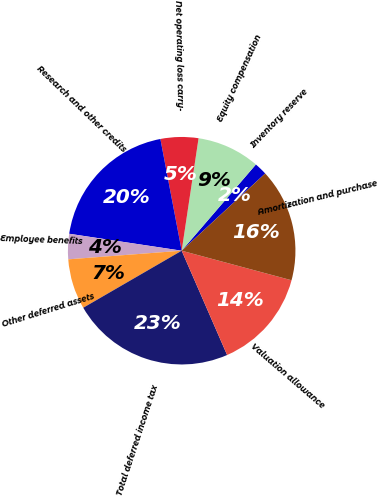<chart> <loc_0><loc_0><loc_500><loc_500><pie_chart><fcel>Inventory reserve<fcel>Equity compensation<fcel>Net operating loss carry-<fcel>Research and other credits<fcel>Employee benefits<fcel>Other deferred assets<fcel>Total deferred income tax<fcel>Valuation allowance<fcel>Amortization and purchase<nl><fcel>1.81%<fcel>8.94%<fcel>5.37%<fcel>19.62%<fcel>3.59%<fcel>7.15%<fcel>23.18%<fcel>14.28%<fcel>16.06%<nl></chart> 